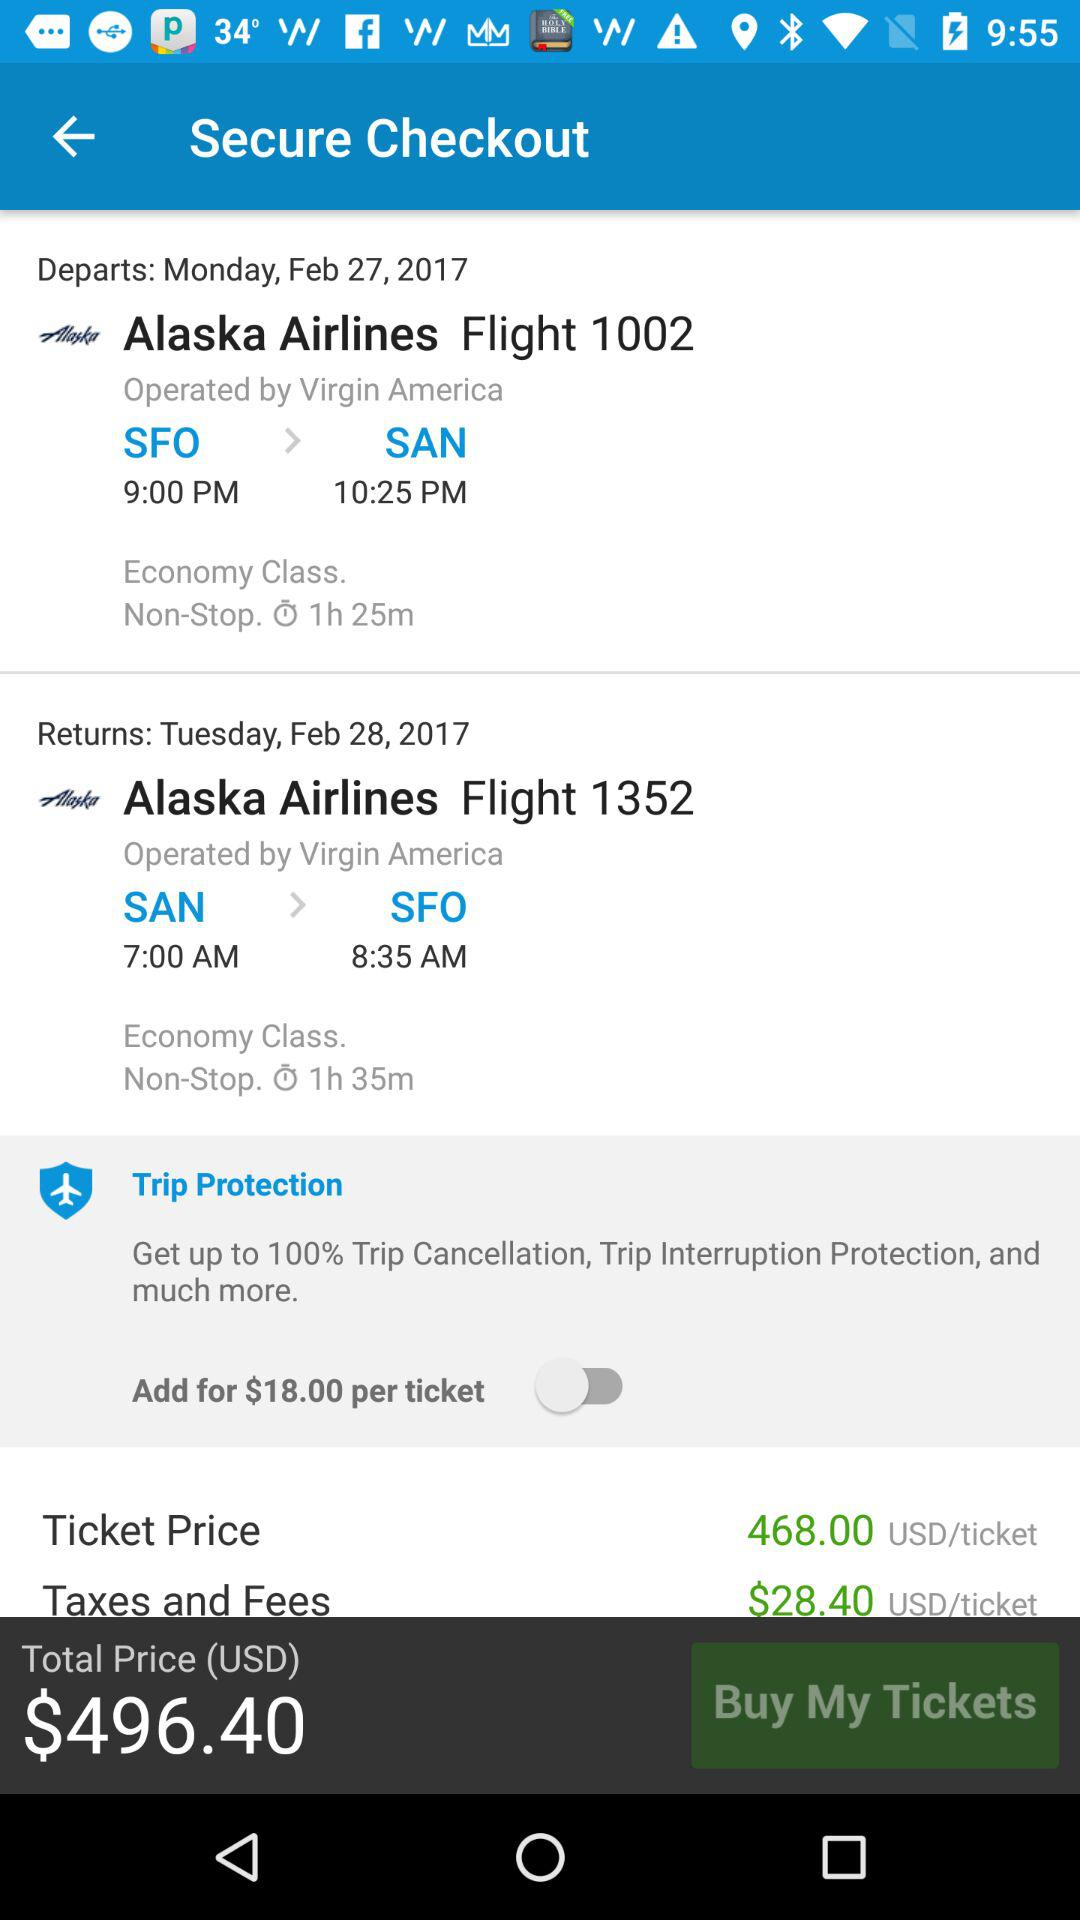How much more does the trip protection cost per ticket?
Answer the question using a single word or phrase. $18.00 